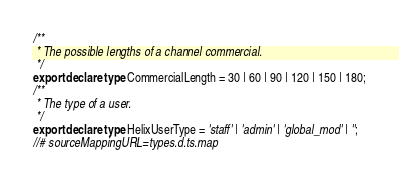<code> <loc_0><loc_0><loc_500><loc_500><_TypeScript_>/**
 * The possible lengths of a channel commercial.
 */
export declare type CommercialLength = 30 | 60 | 90 | 120 | 150 | 180;
/**
 * The type of a user.
 */
export declare type HelixUserType = 'staff' | 'admin' | 'global_mod' | '';
//# sourceMappingURL=types.d.ts.map</code> 